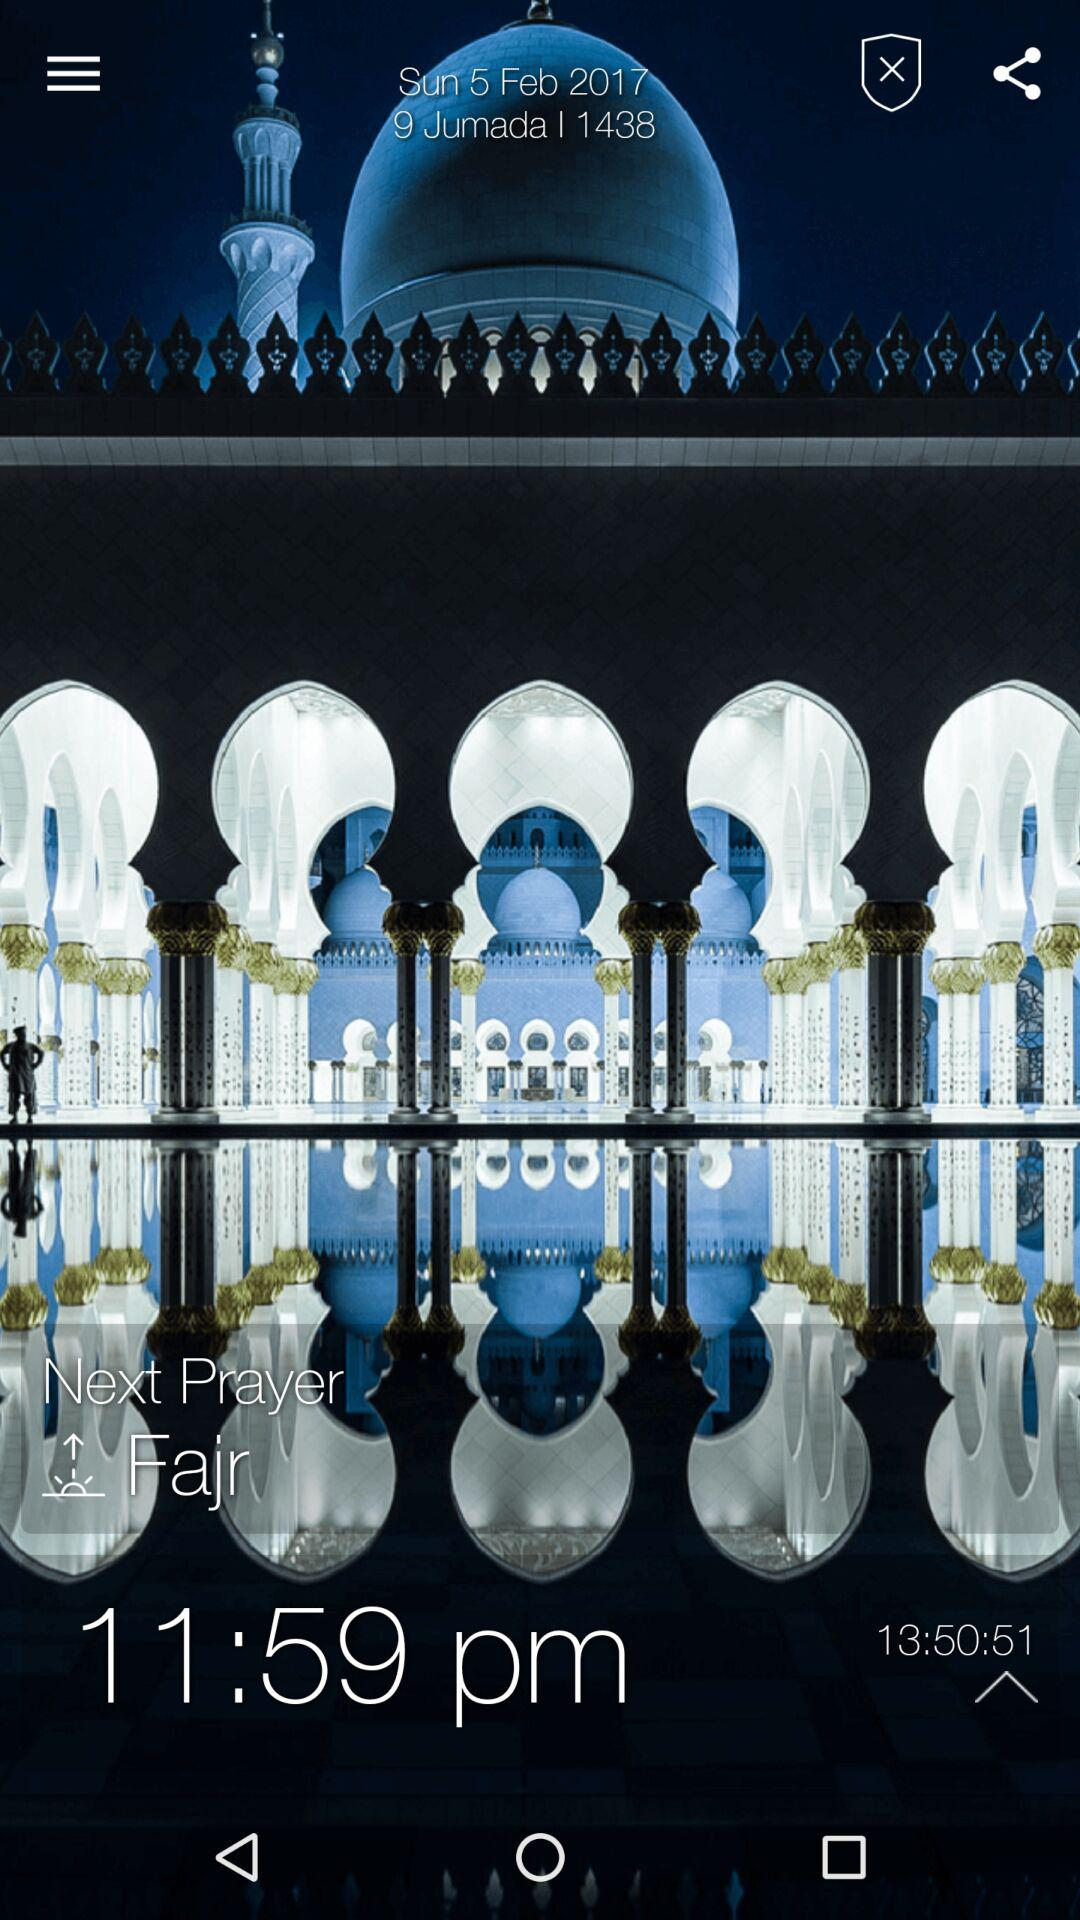What is the day on February 5, 2017? The day is Sunday. 